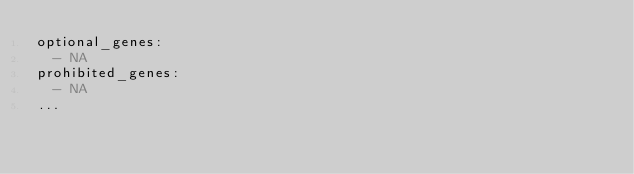<code> <loc_0><loc_0><loc_500><loc_500><_YAML_>optional_genes:
  - NA
prohibited_genes:
  - NA
...
</code> 